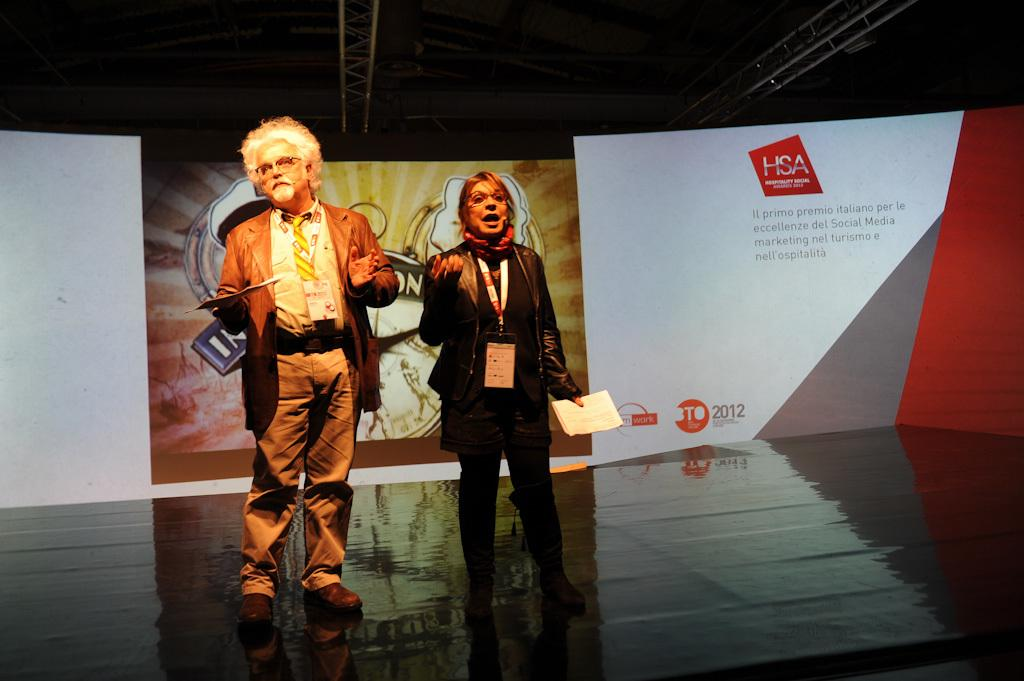Who are the two people in the image? There is a man and a lady in the image. Where are they located in the image? They are standing on a stage. What are they holding in their hands? They are holding papers in their hands. What can be seen in the background of the image? There are boards in the background of the image. What is visible at the top of the image? There is a roof visible at the top of the image. What color is the goldfish swimming in the image? There is no goldfish present in the image. What type of shirt is the lady wearing in the image? The provided facts do not mention the lady's shirt, so we cannot determine its type or color from the image. 